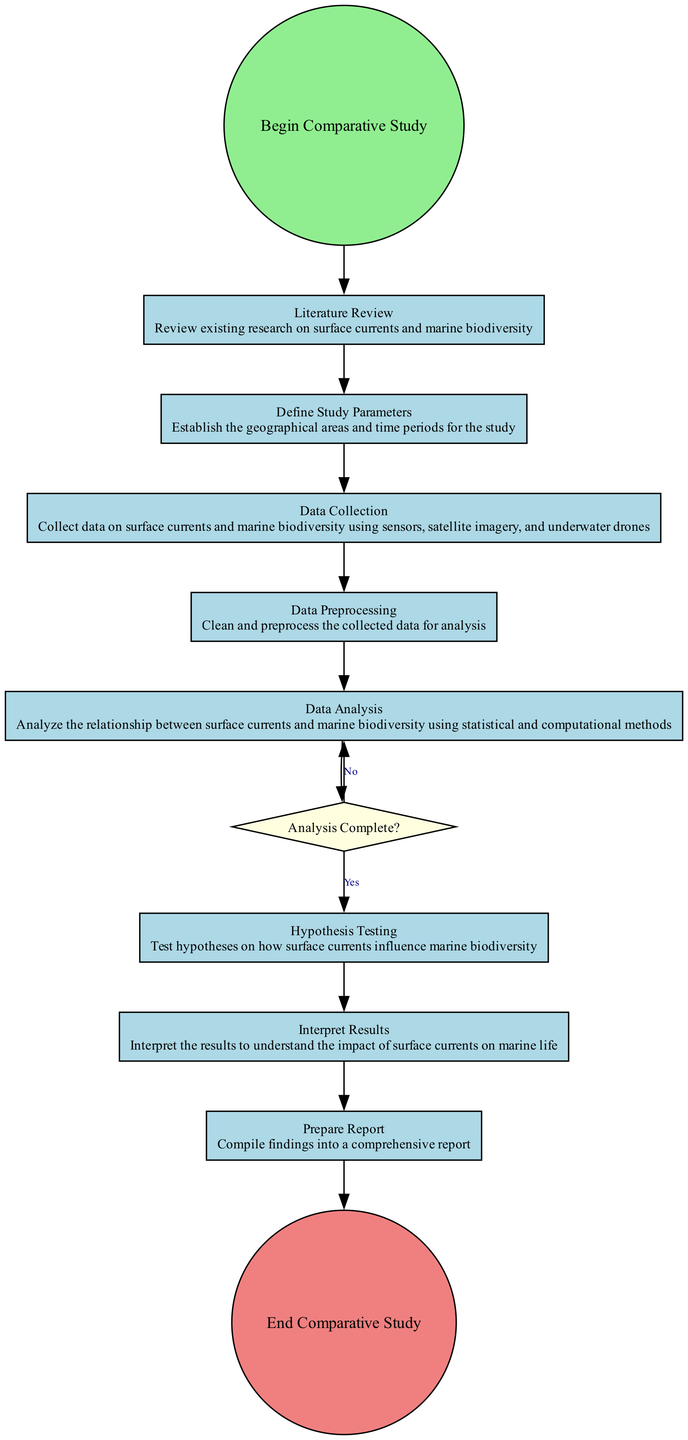What is the first activity in the study? The first activity, as indicated in the diagram, is "Literature Review." It directly follows the starting event.
Answer: Literature Review How many activities are there in total? The diagram lists eight activities from the start to the end of the study, including the literature review and the report preparation.
Answer: Eight What is the condition for proceeding to hypothesis testing? The condition to proceed to hypothesis testing is the completion of the data analysis, which is validated by the decision node labeled "Analysis Complete?" with a "Yes" response.
Answer: Yes Which activity follows the data preprocessing step? After the "Data Preprocessing," the flow continues to "Data Analysis," indicating the sequential order of tasks within the study.
Answer: Data Analysis What is the final step in the comparative study? The last activity outlined in the diagram, following the interpretation of results, is "Prepare Report," which concludes the process.
Answer: Prepare Report What is the function of the decision node in this diagram? The decision node, titled "Analysis Complete?", serves as a checkpoint that determines whether to proceed to the hypothesis testing or to continue with data analysis based on the analysis's completion status.
Answer: Checkpoint What happens if the data analysis is not complete? If the data analysis is not complete, the flow goes back to the "Data Analysis" activity, indicating a loop until adequate analysis is achieved.
Answer: Loop back to Data Analysis What is the role of the “Prepare Report” activity? The "Prepare Report" activity compiles all findings and conclusions drawn from the previous analysis and interpretations into one comprehensive document, serving as the concluding step of the study.
Answer: Compile findings 